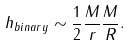Convert formula to latex. <formula><loc_0><loc_0><loc_500><loc_500>h _ { b i n a r y } \sim \frac { 1 } { 2 } \frac { M } { r } \frac { M } { R } .</formula> 